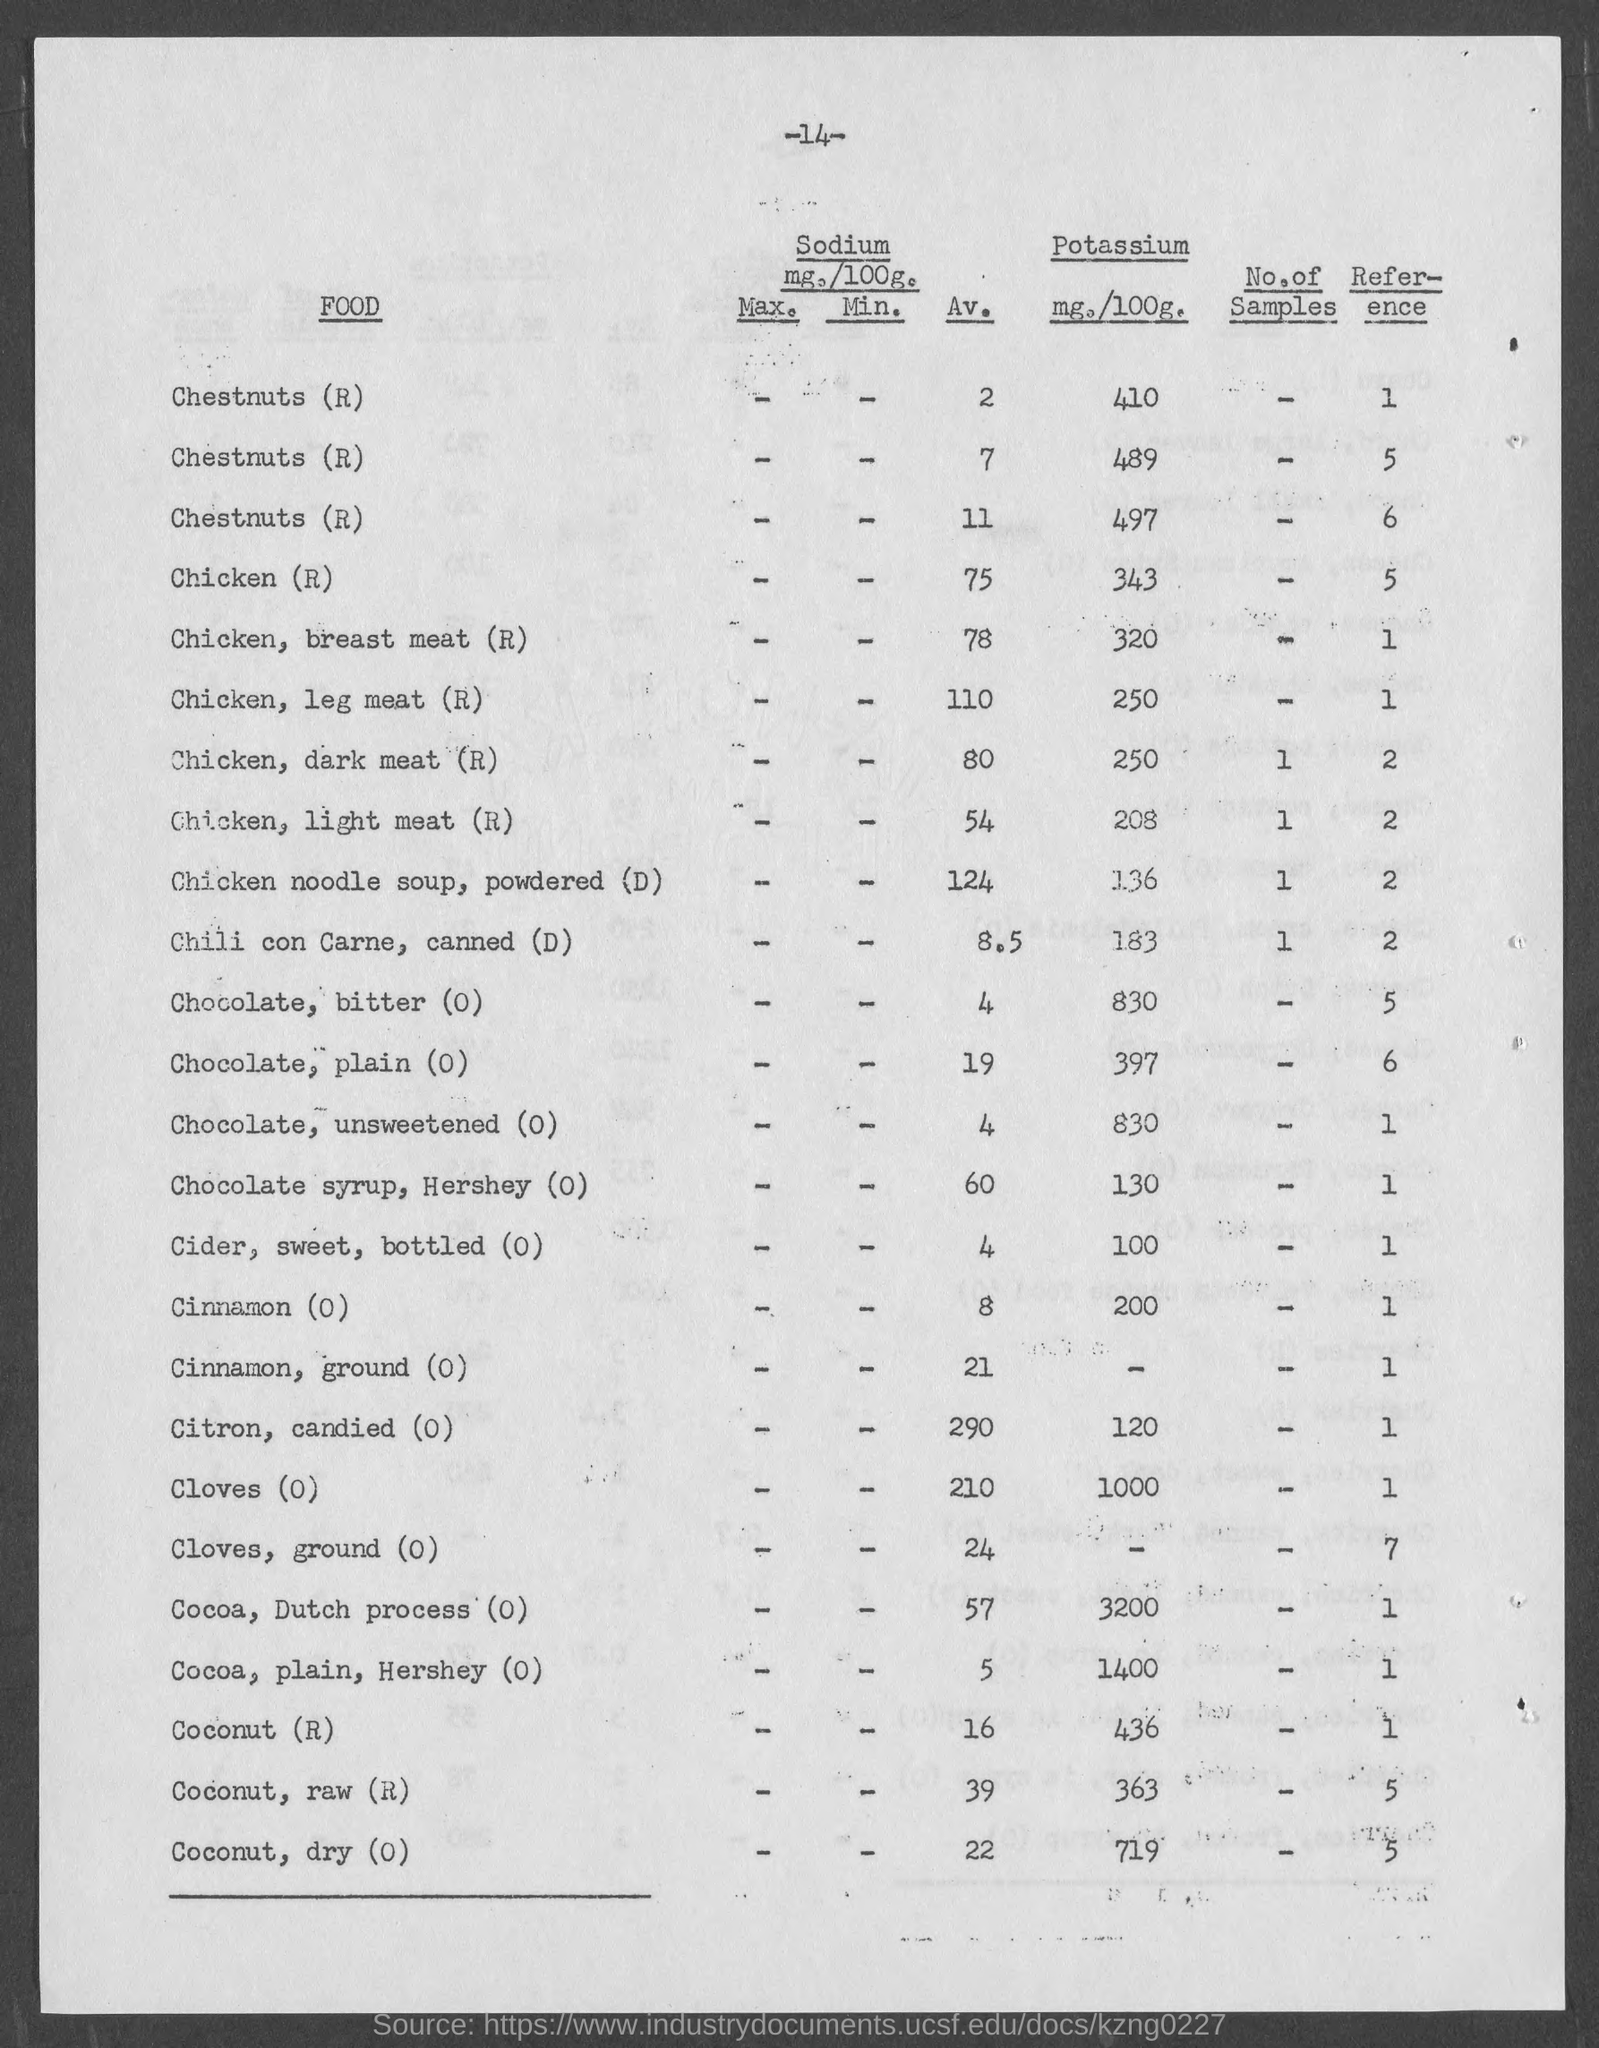Point out several critical features in this image. The amount of potassium in 100 grams of chicken breast meat (R) is 320 milligrams. The number at the top of the page is 14. The amount of potassium in chocolate, bitter (O) is 830 mg per 100g. The amount of potassium in 100 grams of chicken leg meat (R) is 250 milligrams. The amount of potassium in 100 grams of powdered chicken noodle soup is 136 milligrams. 